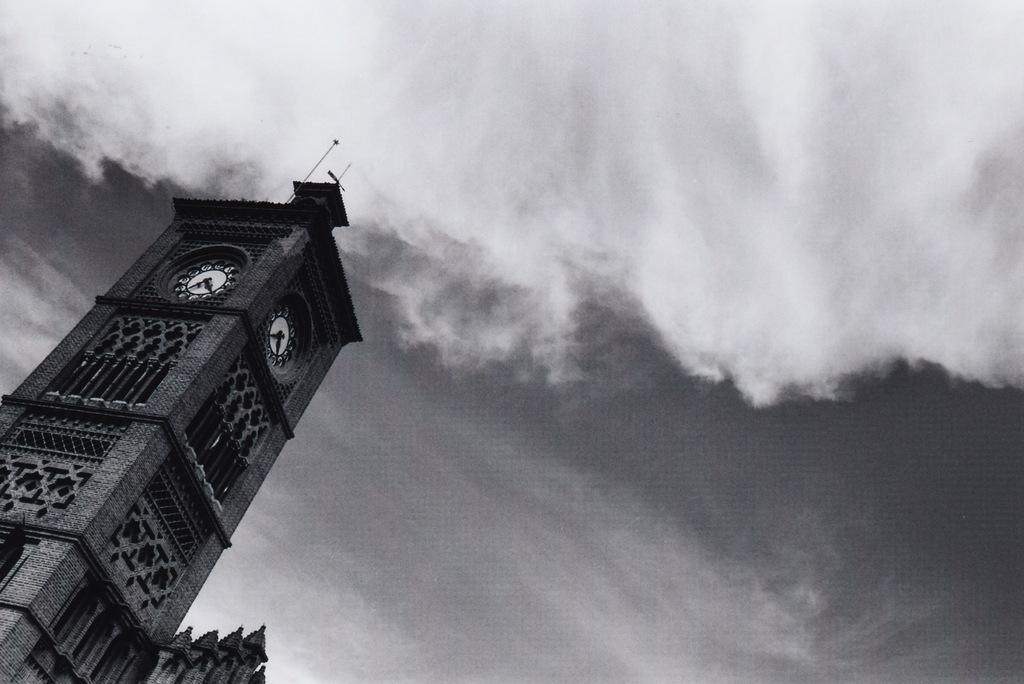What is the color scheme of the image? The image is in black and white. What structure can be seen on the left side of the image? There is a clock tower on the left side of the image. What can be seen in the background of the image? The sky is visible in the background of the image. What is present in the sky? Clouds are present in the sky. What type of spot can be seen growing on the clock tower in the image? There is no spot visible on the clock tower in the image, and it is not growing. 